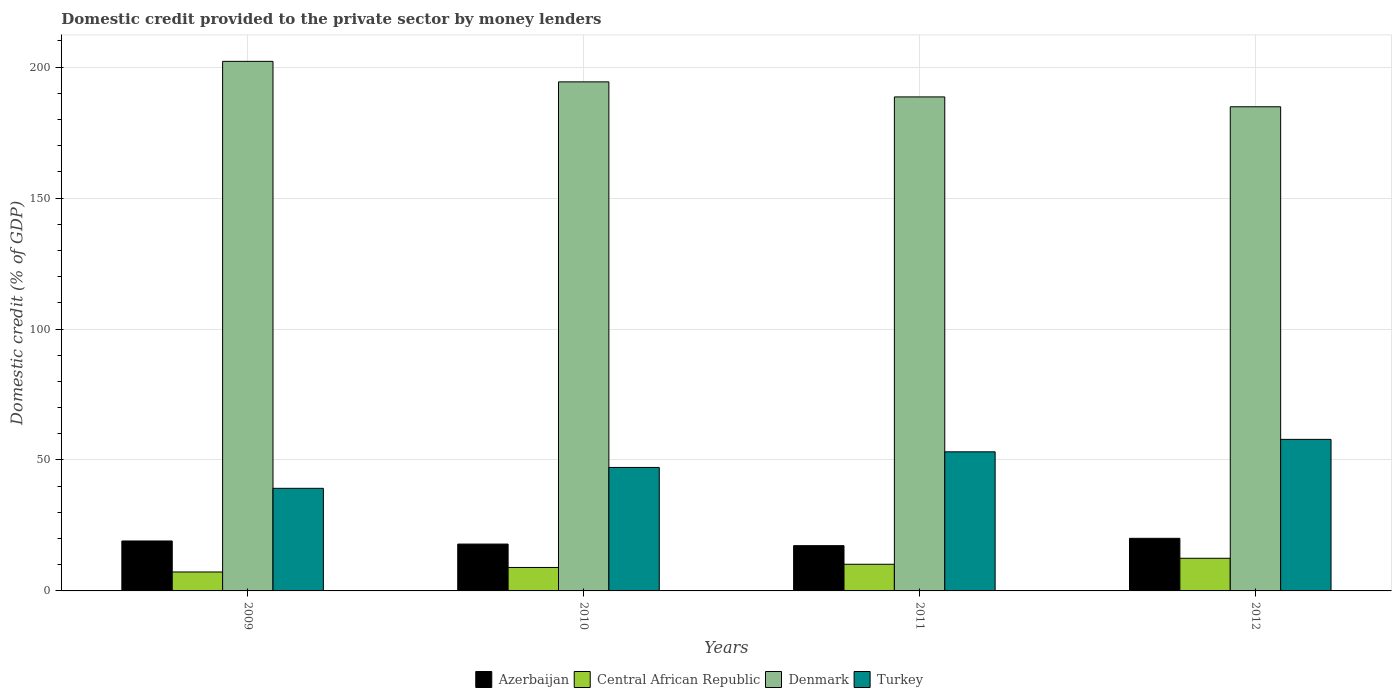Are the number of bars per tick equal to the number of legend labels?
Your response must be concise. Yes. Are the number of bars on each tick of the X-axis equal?
Provide a succinct answer. Yes. How many bars are there on the 1st tick from the left?
Ensure brevity in your answer.  4. How many bars are there on the 2nd tick from the right?
Offer a very short reply. 4. What is the label of the 1st group of bars from the left?
Keep it short and to the point. 2009. What is the domestic credit provided to the private sector by money lenders in Denmark in 2012?
Your answer should be very brief. 184.85. Across all years, what is the maximum domestic credit provided to the private sector by money lenders in Central African Republic?
Offer a terse response. 12.46. Across all years, what is the minimum domestic credit provided to the private sector by money lenders in Denmark?
Ensure brevity in your answer.  184.85. In which year was the domestic credit provided to the private sector by money lenders in Azerbaijan maximum?
Your answer should be very brief. 2012. In which year was the domestic credit provided to the private sector by money lenders in Central African Republic minimum?
Your response must be concise. 2009. What is the total domestic credit provided to the private sector by money lenders in Azerbaijan in the graph?
Your answer should be very brief. 74.32. What is the difference between the domestic credit provided to the private sector by money lenders in Turkey in 2010 and that in 2011?
Your answer should be very brief. -5.97. What is the difference between the domestic credit provided to the private sector by money lenders in Central African Republic in 2011 and the domestic credit provided to the private sector by money lenders in Azerbaijan in 2009?
Offer a very short reply. -8.89. What is the average domestic credit provided to the private sector by money lenders in Turkey per year?
Your answer should be compact. 49.32. In the year 2009, what is the difference between the domestic credit provided to the private sector by money lenders in Azerbaijan and domestic credit provided to the private sector by money lenders in Turkey?
Your response must be concise. -20.11. What is the ratio of the domestic credit provided to the private sector by money lenders in Central African Republic in 2009 to that in 2011?
Your answer should be very brief. 0.71. Is the domestic credit provided to the private sector by money lenders in Denmark in 2009 less than that in 2010?
Provide a succinct answer. No. Is the difference between the domestic credit provided to the private sector by money lenders in Azerbaijan in 2009 and 2011 greater than the difference between the domestic credit provided to the private sector by money lenders in Turkey in 2009 and 2011?
Ensure brevity in your answer.  Yes. What is the difference between the highest and the second highest domestic credit provided to the private sector by money lenders in Central African Republic?
Your answer should be very brief. 2.28. What is the difference between the highest and the lowest domestic credit provided to the private sector by money lenders in Azerbaijan?
Keep it short and to the point. 2.8. Is it the case that in every year, the sum of the domestic credit provided to the private sector by money lenders in Azerbaijan and domestic credit provided to the private sector by money lenders in Denmark is greater than the sum of domestic credit provided to the private sector by money lenders in Turkey and domestic credit provided to the private sector by money lenders in Central African Republic?
Ensure brevity in your answer.  Yes. What does the 4th bar from the right in 2009 represents?
Your answer should be compact. Azerbaijan. How many bars are there?
Give a very brief answer. 16. How many years are there in the graph?
Provide a short and direct response. 4. Are the values on the major ticks of Y-axis written in scientific E-notation?
Your response must be concise. No. Does the graph contain grids?
Ensure brevity in your answer.  Yes. Where does the legend appear in the graph?
Keep it short and to the point. Bottom center. How many legend labels are there?
Your response must be concise. 4. What is the title of the graph?
Your answer should be compact. Domestic credit provided to the private sector by money lenders. What is the label or title of the Y-axis?
Give a very brief answer. Domestic credit (% of GDP). What is the Domestic credit (% of GDP) of Azerbaijan in 2009?
Your answer should be very brief. 19.07. What is the Domestic credit (% of GDP) in Central African Republic in 2009?
Provide a succinct answer. 7.23. What is the Domestic credit (% of GDP) in Denmark in 2009?
Your answer should be very brief. 202.19. What is the Domestic credit (% of GDP) of Turkey in 2009?
Offer a very short reply. 39.18. What is the Domestic credit (% of GDP) in Azerbaijan in 2010?
Ensure brevity in your answer.  17.88. What is the Domestic credit (% of GDP) in Central African Republic in 2010?
Ensure brevity in your answer.  8.96. What is the Domestic credit (% of GDP) of Denmark in 2010?
Provide a short and direct response. 194.36. What is the Domestic credit (% of GDP) of Turkey in 2010?
Keep it short and to the point. 47.14. What is the Domestic credit (% of GDP) in Azerbaijan in 2011?
Provide a short and direct response. 17.28. What is the Domestic credit (% of GDP) in Central African Republic in 2011?
Keep it short and to the point. 10.18. What is the Domestic credit (% of GDP) of Denmark in 2011?
Make the answer very short. 188.61. What is the Domestic credit (% of GDP) of Turkey in 2011?
Your answer should be compact. 53.11. What is the Domestic credit (% of GDP) in Azerbaijan in 2012?
Keep it short and to the point. 20.09. What is the Domestic credit (% of GDP) in Central African Republic in 2012?
Your answer should be very brief. 12.46. What is the Domestic credit (% of GDP) of Denmark in 2012?
Keep it short and to the point. 184.85. What is the Domestic credit (% of GDP) of Turkey in 2012?
Offer a very short reply. 57.86. Across all years, what is the maximum Domestic credit (% of GDP) of Azerbaijan?
Your answer should be compact. 20.09. Across all years, what is the maximum Domestic credit (% of GDP) in Central African Republic?
Give a very brief answer. 12.46. Across all years, what is the maximum Domestic credit (% of GDP) in Denmark?
Offer a terse response. 202.19. Across all years, what is the maximum Domestic credit (% of GDP) in Turkey?
Provide a succinct answer. 57.86. Across all years, what is the minimum Domestic credit (% of GDP) in Azerbaijan?
Provide a short and direct response. 17.28. Across all years, what is the minimum Domestic credit (% of GDP) in Central African Republic?
Your answer should be compact. 7.23. Across all years, what is the minimum Domestic credit (% of GDP) of Denmark?
Offer a terse response. 184.85. Across all years, what is the minimum Domestic credit (% of GDP) in Turkey?
Give a very brief answer. 39.18. What is the total Domestic credit (% of GDP) of Azerbaijan in the graph?
Keep it short and to the point. 74.32. What is the total Domestic credit (% of GDP) in Central African Republic in the graph?
Provide a short and direct response. 38.83. What is the total Domestic credit (% of GDP) of Denmark in the graph?
Offer a very short reply. 770.01. What is the total Domestic credit (% of GDP) of Turkey in the graph?
Keep it short and to the point. 197.29. What is the difference between the Domestic credit (% of GDP) in Azerbaijan in 2009 and that in 2010?
Offer a terse response. 1.18. What is the difference between the Domestic credit (% of GDP) of Central African Republic in 2009 and that in 2010?
Keep it short and to the point. -1.72. What is the difference between the Domestic credit (% of GDP) in Denmark in 2009 and that in 2010?
Ensure brevity in your answer.  7.83. What is the difference between the Domestic credit (% of GDP) of Turkey in 2009 and that in 2010?
Offer a terse response. -7.97. What is the difference between the Domestic credit (% of GDP) of Azerbaijan in 2009 and that in 2011?
Your answer should be compact. 1.78. What is the difference between the Domestic credit (% of GDP) in Central African Republic in 2009 and that in 2011?
Offer a very short reply. -2.95. What is the difference between the Domestic credit (% of GDP) of Denmark in 2009 and that in 2011?
Give a very brief answer. 13.57. What is the difference between the Domestic credit (% of GDP) in Turkey in 2009 and that in 2011?
Your answer should be very brief. -13.93. What is the difference between the Domestic credit (% of GDP) of Azerbaijan in 2009 and that in 2012?
Provide a short and direct response. -1.02. What is the difference between the Domestic credit (% of GDP) in Central African Republic in 2009 and that in 2012?
Your response must be concise. -5.23. What is the difference between the Domestic credit (% of GDP) of Denmark in 2009 and that in 2012?
Offer a very short reply. 17.34. What is the difference between the Domestic credit (% of GDP) of Turkey in 2009 and that in 2012?
Your answer should be very brief. -18.69. What is the difference between the Domestic credit (% of GDP) in Azerbaijan in 2010 and that in 2011?
Make the answer very short. 0.6. What is the difference between the Domestic credit (% of GDP) of Central African Republic in 2010 and that in 2011?
Provide a succinct answer. -1.23. What is the difference between the Domestic credit (% of GDP) in Denmark in 2010 and that in 2011?
Make the answer very short. 5.74. What is the difference between the Domestic credit (% of GDP) of Turkey in 2010 and that in 2011?
Offer a terse response. -5.97. What is the difference between the Domestic credit (% of GDP) of Azerbaijan in 2010 and that in 2012?
Make the answer very short. -2.2. What is the difference between the Domestic credit (% of GDP) of Central African Republic in 2010 and that in 2012?
Give a very brief answer. -3.51. What is the difference between the Domestic credit (% of GDP) of Denmark in 2010 and that in 2012?
Your response must be concise. 9.51. What is the difference between the Domestic credit (% of GDP) in Turkey in 2010 and that in 2012?
Offer a very short reply. -10.72. What is the difference between the Domestic credit (% of GDP) of Azerbaijan in 2011 and that in 2012?
Ensure brevity in your answer.  -2.8. What is the difference between the Domestic credit (% of GDP) of Central African Republic in 2011 and that in 2012?
Provide a short and direct response. -2.28. What is the difference between the Domestic credit (% of GDP) in Denmark in 2011 and that in 2012?
Your answer should be compact. 3.77. What is the difference between the Domestic credit (% of GDP) of Turkey in 2011 and that in 2012?
Offer a very short reply. -4.75. What is the difference between the Domestic credit (% of GDP) in Azerbaijan in 2009 and the Domestic credit (% of GDP) in Central African Republic in 2010?
Provide a succinct answer. 10.11. What is the difference between the Domestic credit (% of GDP) of Azerbaijan in 2009 and the Domestic credit (% of GDP) of Denmark in 2010?
Make the answer very short. -175.29. What is the difference between the Domestic credit (% of GDP) in Azerbaijan in 2009 and the Domestic credit (% of GDP) in Turkey in 2010?
Your response must be concise. -28.08. What is the difference between the Domestic credit (% of GDP) of Central African Republic in 2009 and the Domestic credit (% of GDP) of Denmark in 2010?
Provide a succinct answer. -187.12. What is the difference between the Domestic credit (% of GDP) in Central African Republic in 2009 and the Domestic credit (% of GDP) in Turkey in 2010?
Your answer should be compact. -39.91. What is the difference between the Domestic credit (% of GDP) of Denmark in 2009 and the Domestic credit (% of GDP) of Turkey in 2010?
Offer a very short reply. 155.05. What is the difference between the Domestic credit (% of GDP) of Azerbaijan in 2009 and the Domestic credit (% of GDP) of Central African Republic in 2011?
Your answer should be compact. 8.89. What is the difference between the Domestic credit (% of GDP) in Azerbaijan in 2009 and the Domestic credit (% of GDP) in Denmark in 2011?
Provide a succinct answer. -169.55. What is the difference between the Domestic credit (% of GDP) in Azerbaijan in 2009 and the Domestic credit (% of GDP) in Turkey in 2011?
Give a very brief answer. -34.04. What is the difference between the Domestic credit (% of GDP) of Central African Republic in 2009 and the Domestic credit (% of GDP) of Denmark in 2011?
Make the answer very short. -181.38. What is the difference between the Domestic credit (% of GDP) in Central African Republic in 2009 and the Domestic credit (% of GDP) in Turkey in 2011?
Your answer should be very brief. -45.88. What is the difference between the Domestic credit (% of GDP) in Denmark in 2009 and the Domestic credit (% of GDP) in Turkey in 2011?
Your response must be concise. 149.08. What is the difference between the Domestic credit (% of GDP) in Azerbaijan in 2009 and the Domestic credit (% of GDP) in Central African Republic in 2012?
Your answer should be compact. 6.6. What is the difference between the Domestic credit (% of GDP) of Azerbaijan in 2009 and the Domestic credit (% of GDP) of Denmark in 2012?
Offer a very short reply. -165.78. What is the difference between the Domestic credit (% of GDP) in Azerbaijan in 2009 and the Domestic credit (% of GDP) in Turkey in 2012?
Your response must be concise. -38.8. What is the difference between the Domestic credit (% of GDP) of Central African Republic in 2009 and the Domestic credit (% of GDP) of Denmark in 2012?
Your answer should be compact. -177.62. What is the difference between the Domestic credit (% of GDP) in Central African Republic in 2009 and the Domestic credit (% of GDP) in Turkey in 2012?
Your response must be concise. -50.63. What is the difference between the Domestic credit (% of GDP) of Denmark in 2009 and the Domestic credit (% of GDP) of Turkey in 2012?
Make the answer very short. 144.33. What is the difference between the Domestic credit (% of GDP) in Azerbaijan in 2010 and the Domestic credit (% of GDP) in Central African Republic in 2011?
Make the answer very short. 7.7. What is the difference between the Domestic credit (% of GDP) of Azerbaijan in 2010 and the Domestic credit (% of GDP) of Denmark in 2011?
Your answer should be very brief. -170.73. What is the difference between the Domestic credit (% of GDP) in Azerbaijan in 2010 and the Domestic credit (% of GDP) in Turkey in 2011?
Your answer should be very brief. -35.22. What is the difference between the Domestic credit (% of GDP) of Central African Republic in 2010 and the Domestic credit (% of GDP) of Denmark in 2011?
Make the answer very short. -179.66. What is the difference between the Domestic credit (% of GDP) in Central African Republic in 2010 and the Domestic credit (% of GDP) in Turkey in 2011?
Your response must be concise. -44.15. What is the difference between the Domestic credit (% of GDP) in Denmark in 2010 and the Domestic credit (% of GDP) in Turkey in 2011?
Ensure brevity in your answer.  141.25. What is the difference between the Domestic credit (% of GDP) in Azerbaijan in 2010 and the Domestic credit (% of GDP) in Central African Republic in 2012?
Provide a succinct answer. 5.42. What is the difference between the Domestic credit (% of GDP) in Azerbaijan in 2010 and the Domestic credit (% of GDP) in Denmark in 2012?
Offer a terse response. -166.96. What is the difference between the Domestic credit (% of GDP) of Azerbaijan in 2010 and the Domestic credit (% of GDP) of Turkey in 2012?
Provide a short and direct response. -39.98. What is the difference between the Domestic credit (% of GDP) in Central African Republic in 2010 and the Domestic credit (% of GDP) in Denmark in 2012?
Your answer should be very brief. -175.89. What is the difference between the Domestic credit (% of GDP) in Central African Republic in 2010 and the Domestic credit (% of GDP) in Turkey in 2012?
Ensure brevity in your answer.  -48.91. What is the difference between the Domestic credit (% of GDP) in Denmark in 2010 and the Domestic credit (% of GDP) in Turkey in 2012?
Offer a very short reply. 136.49. What is the difference between the Domestic credit (% of GDP) in Azerbaijan in 2011 and the Domestic credit (% of GDP) in Central African Republic in 2012?
Offer a terse response. 4.82. What is the difference between the Domestic credit (% of GDP) of Azerbaijan in 2011 and the Domestic credit (% of GDP) of Denmark in 2012?
Provide a succinct answer. -167.57. What is the difference between the Domestic credit (% of GDP) of Azerbaijan in 2011 and the Domestic credit (% of GDP) of Turkey in 2012?
Ensure brevity in your answer.  -40.58. What is the difference between the Domestic credit (% of GDP) in Central African Republic in 2011 and the Domestic credit (% of GDP) in Denmark in 2012?
Keep it short and to the point. -174.67. What is the difference between the Domestic credit (% of GDP) in Central African Republic in 2011 and the Domestic credit (% of GDP) in Turkey in 2012?
Offer a terse response. -47.68. What is the difference between the Domestic credit (% of GDP) of Denmark in 2011 and the Domestic credit (% of GDP) of Turkey in 2012?
Your response must be concise. 130.75. What is the average Domestic credit (% of GDP) of Azerbaijan per year?
Your answer should be very brief. 18.58. What is the average Domestic credit (% of GDP) of Central African Republic per year?
Offer a very short reply. 9.71. What is the average Domestic credit (% of GDP) of Denmark per year?
Your response must be concise. 192.5. What is the average Domestic credit (% of GDP) in Turkey per year?
Offer a terse response. 49.32. In the year 2009, what is the difference between the Domestic credit (% of GDP) in Azerbaijan and Domestic credit (% of GDP) in Central African Republic?
Your answer should be very brief. 11.83. In the year 2009, what is the difference between the Domestic credit (% of GDP) in Azerbaijan and Domestic credit (% of GDP) in Denmark?
Your response must be concise. -183.12. In the year 2009, what is the difference between the Domestic credit (% of GDP) of Azerbaijan and Domestic credit (% of GDP) of Turkey?
Offer a terse response. -20.11. In the year 2009, what is the difference between the Domestic credit (% of GDP) in Central African Republic and Domestic credit (% of GDP) in Denmark?
Provide a short and direct response. -194.96. In the year 2009, what is the difference between the Domestic credit (% of GDP) of Central African Republic and Domestic credit (% of GDP) of Turkey?
Your answer should be compact. -31.94. In the year 2009, what is the difference between the Domestic credit (% of GDP) of Denmark and Domestic credit (% of GDP) of Turkey?
Your response must be concise. 163.01. In the year 2010, what is the difference between the Domestic credit (% of GDP) of Azerbaijan and Domestic credit (% of GDP) of Central African Republic?
Give a very brief answer. 8.93. In the year 2010, what is the difference between the Domestic credit (% of GDP) in Azerbaijan and Domestic credit (% of GDP) in Denmark?
Offer a terse response. -176.47. In the year 2010, what is the difference between the Domestic credit (% of GDP) of Azerbaijan and Domestic credit (% of GDP) of Turkey?
Provide a succinct answer. -29.26. In the year 2010, what is the difference between the Domestic credit (% of GDP) in Central African Republic and Domestic credit (% of GDP) in Denmark?
Give a very brief answer. -185.4. In the year 2010, what is the difference between the Domestic credit (% of GDP) of Central African Republic and Domestic credit (% of GDP) of Turkey?
Offer a very short reply. -38.19. In the year 2010, what is the difference between the Domestic credit (% of GDP) of Denmark and Domestic credit (% of GDP) of Turkey?
Provide a succinct answer. 147.21. In the year 2011, what is the difference between the Domestic credit (% of GDP) in Azerbaijan and Domestic credit (% of GDP) in Central African Republic?
Provide a short and direct response. 7.1. In the year 2011, what is the difference between the Domestic credit (% of GDP) of Azerbaijan and Domestic credit (% of GDP) of Denmark?
Provide a short and direct response. -171.33. In the year 2011, what is the difference between the Domestic credit (% of GDP) in Azerbaijan and Domestic credit (% of GDP) in Turkey?
Your answer should be very brief. -35.83. In the year 2011, what is the difference between the Domestic credit (% of GDP) of Central African Republic and Domestic credit (% of GDP) of Denmark?
Give a very brief answer. -178.43. In the year 2011, what is the difference between the Domestic credit (% of GDP) of Central African Republic and Domestic credit (% of GDP) of Turkey?
Offer a terse response. -42.93. In the year 2011, what is the difference between the Domestic credit (% of GDP) in Denmark and Domestic credit (% of GDP) in Turkey?
Provide a succinct answer. 135.51. In the year 2012, what is the difference between the Domestic credit (% of GDP) of Azerbaijan and Domestic credit (% of GDP) of Central African Republic?
Provide a short and direct response. 7.62. In the year 2012, what is the difference between the Domestic credit (% of GDP) of Azerbaijan and Domestic credit (% of GDP) of Denmark?
Keep it short and to the point. -164.76. In the year 2012, what is the difference between the Domestic credit (% of GDP) of Azerbaijan and Domestic credit (% of GDP) of Turkey?
Keep it short and to the point. -37.78. In the year 2012, what is the difference between the Domestic credit (% of GDP) of Central African Republic and Domestic credit (% of GDP) of Denmark?
Ensure brevity in your answer.  -172.39. In the year 2012, what is the difference between the Domestic credit (% of GDP) in Central African Republic and Domestic credit (% of GDP) in Turkey?
Your answer should be very brief. -45.4. In the year 2012, what is the difference between the Domestic credit (% of GDP) of Denmark and Domestic credit (% of GDP) of Turkey?
Make the answer very short. 126.99. What is the ratio of the Domestic credit (% of GDP) in Azerbaijan in 2009 to that in 2010?
Offer a terse response. 1.07. What is the ratio of the Domestic credit (% of GDP) of Central African Republic in 2009 to that in 2010?
Keep it short and to the point. 0.81. What is the ratio of the Domestic credit (% of GDP) of Denmark in 2009 to that in 2010?
Offer a very short reply. 1.04. What is the ratio of the Domestic credit (% of GDP) in Turkey in 2009 to that in 2010?
Your response must be concise. 0.83. What is the ratio of the Domestic credit (% of GDP) of Azerbaijan in 2009 to that in 2011?
Make the answer very short. 1.1. What is the ratio of the Domestic credit (% of GDP) of Central African Republic in 2009 to that in 2011?
Make the answer very short. 0.71. What is the ratio of the Domestic credit (% of GDP) of Denmark in 2009 to that in 2011?
Your answer should be very brief. 1.07. What is the ratio of the Domestic credit (% of GDP) in Turkey in 2009 to that in 2011?
Your response must be concise. 0.74. What is the ratio of the Domestic credit (% of GDP) in Azerbaijan in 2009 to that in 2012?
Your response must be concise. 0.95. What is the ratio of the Domestic credit (% of GDP) in Central African Republic in 2009 to that in 2012?
Your response must be concise. 0.58. What is the ratio of the Domestic credit (% of GDP) in Denmark in 2009 to that in 2012?
Keep it short and to the point. 1.09. What is the ratio of the Domestic credit (% of GDP) in Turkey in 2009 to that in 2012?
Make the answer very short. 0.68. What is the ratio of the Domestic credit (% of GDP) in Azerbaijan in 2010 to that in 2011?
Offer a terse response. 1.03. What is the ratio of the Domestic credit (% of GDP) in Central African Republic in 2010 to that in 2011?
Keep it short and to the point. 0.88. What is the ratio of the Domestic credit (% of GDP) of Denmark in 2010 to that in 2011?
Your answer should be very brief. 1.03. What is the ratio of the Domestic credit (% of GDP) in Turkey in 2010 to that in 2011?
Your response must be concise. 0.89. What is the ratio of the Domestic credit (% of GDP) of Azerbaijan in 2010 to that in 2012?
Your response must be concise. 0.89. What is the ratio of the Domestic credit (% of GDP) in Central African Republic in 2010 to that in 2012?
Offer a very short reply. 0.72. What is the ratio of the Domestic credit (% of GDP) in Denmark in 2010 to that in 2012?
Your response must be concise. 1.05. What is the ratio of the Domestic credit (% of GDP) in Turkey in 2010 to that in 2012?
Your answer should be compact. 0.81. What is the ratio of the Domestic credit (% of GDP) of Azerbaijan in 2011 to that in 2012?
Offer a very short reply. 0.86. What is the ratio of the Domestic credit (% of GDP) in Central African Republic in 2011 to that in 2012?
Offer a terse response. 0.82. What is the ratio of the Domestic credit (% of GDP) of Denmark in 2011 to that in 2012?
Provide a succinct answer. 1.02. What is the ratio of the Domestic credit (% of GDP) in Turkey in 2011 to that in 2012?
Offer a terse response. 0.92. What is the difference between the highest and the second highest Domestic credit (% of GDP) in Azerbaijan?
Give a very brief answer. 1.02. What is the difference between the highest and the second highest Domestic credit (% of GDP) of Central African Republic?
Make the answer very short. 2.28. What is the difference between the highest and the second highest Domestic credit (% of GDP) of Denmark?
Offer a terse response. 7.83. What is the difference between the highest and the second highest Domestic credit (% of GDP) of Turkey?
Offer a terse response. 4.75. What is the difference between the highest and the lowest Domestic credit (% of GDP) in Azerbaijan?
Ensure brevity in your answer.  2.8. What is the difference between the highest and the lowest Domestic credit (% of GDP) of Central African Republic?
Make the answer very short. 5.23. What is the difference between the highest and the lowest Domestic credit (% of GDP) of Denmark?
Give a very brief answer. 17.34. What is the difference between the highest and the lowest Domestic credit (% of GDP) of Turkey?
Your answer should be compact. 18.69. 